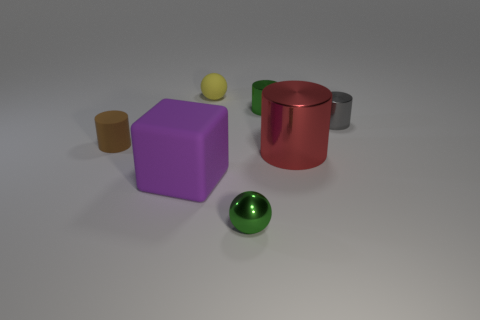Subtract all rubber cylinders. How many cylinders are left? 3 Subtract 1 spheres. How many spheres are left? 1 Add 2 large purple objects. How many large purple objects exist? 3 Add 2 big blue things. How many objects exist? 9 Subtract all green spheres. How many spheres are left? 1 Subtract 0 gray cubes. How many objects are left? 7 Subtract all cylinders. How many objects are left? 3 Subtract all brown cylinders. Subtract all brown spheres. How many cylinders are left? 3 Subtract all blue cylinders. How many red blocks are left? 0 Subtract all brown matte cylinders. Subtract all small matte spheres. How many objects are left? 5 